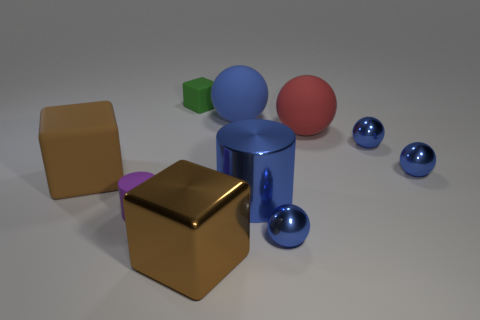What is the shape of the tiny blue shiny object in front of the brown object that is on the left side of the matte cylinder?
Provide a short and direct response. Sphere. What color is the ball that is the same material as the red object?
Make the answer very short. Blue. Do the big matte cube and the large metallic block have the same color?
Provide a short and direct response. Yes. What shape is the red object that is the same size as the blue matte sphere?
Offer a very short reply. Sphere. The green object has what size?
Ensure brevity in your answer.  Small. There is a block that is to the left of the small rubber cylinder; is its size the same as the shiny ball in front of the large brown rubber block?
Keep it short and to the point. No. What color is the matte object that is to the left of the purple object on the left side of the tiny green object?
Your response must be concise. Brown. There is a cylinder that is the same size as the brown shiny cube; what is it made of?
Your answer should be compact. Metal. How many matte objects are either blue balls or brown objects?
Offer a terse response. 2. What is the color of the large thing that is both to the left of the big blue matte thing and behind the metal cylinder?
Offer a terse response. Brown. 